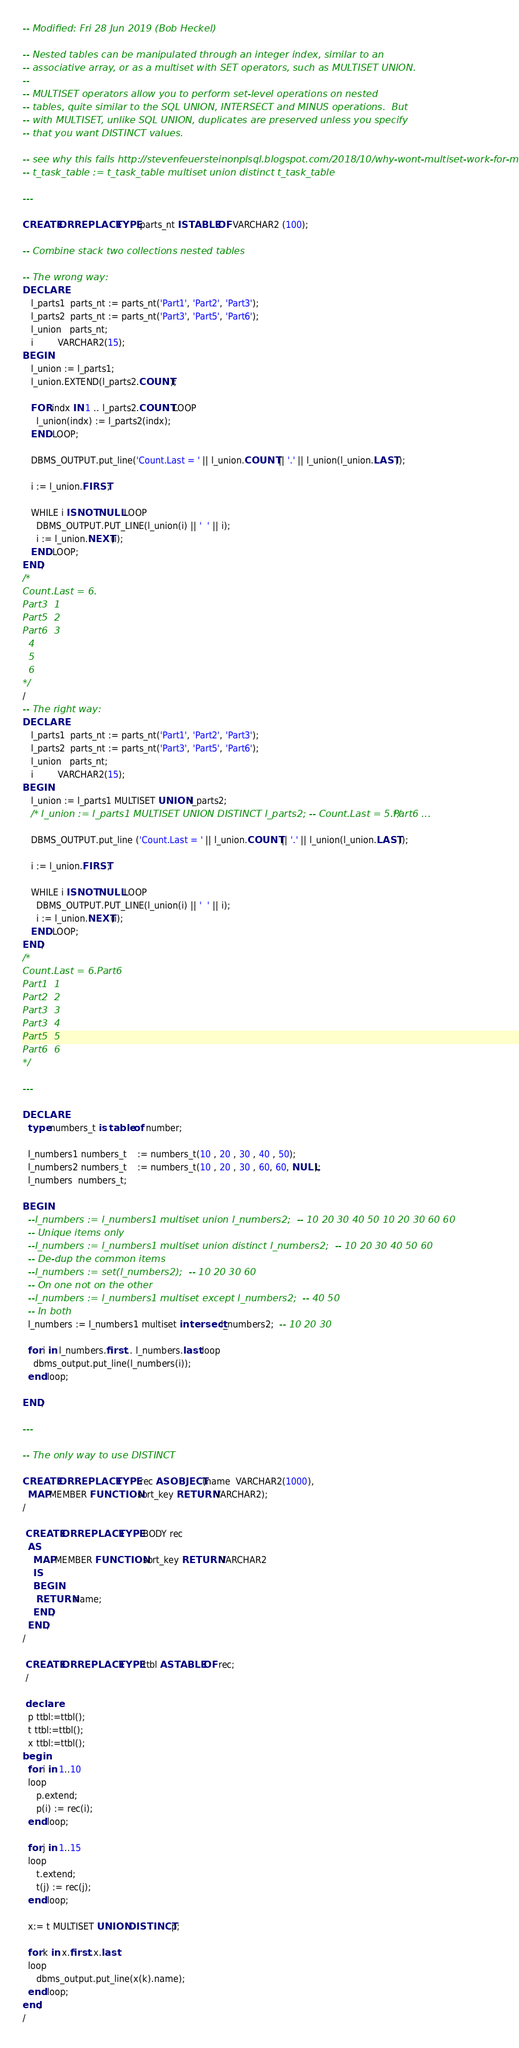Convert code to text. <code><loc_0><loc_0><loc_500><loc_500><_SQL_>-- Modified: Fri 28 Jun 2019 (Bob Heckel)

-- Nested tables can be manipulated through an integer index, similar to an
-- associative array, or as a multiset with SET operators, such as MULTISET UNION.
--
-- MULTISET operators allow you to perform set-level operations on nested
-- tables, quite similar to the SQL UNION, INTERSECT and MINUS operations.  But
-- with MULTISET, unlike SQL UNION, duplicates are preserved unless you specify 
-- that you want DISTINCT values.

-- see why this fails http://stevenfeuersteinonplsql.blogspot.com/2018/10/why-wont-multiset-work-for-me.html
-- t_task_table := t_task_table multiset union distinct t_task_table

---

CREATE OR REPLACE TYPE parts_nt IS TABLE OF VARCHAR2 (100);

-- Combine stack two collections nested tables

-- The wrong way:
DECLARE
   l_parts1  parts_nt := parts_nt('Part1', 'Part2', 'Part3');
   l_parts2  parts_nt := parts_nt('Part3', 'Part5', 'Part6');
   l_union   parts_nt;
   i         VARCHAR2(15);
BEGIN
   l_union := l_parts1;
   l_union.EXTEND(l_parts2.COUNT);

   FOR indx IN 1 .. l_parts2.COUNT LOOP
     l_union(indx) := l_parts2(indx);
   END LOOP;

   DBMS_OUTPUT.put_line('Count.Last = ' || l_union.COUNT || '.' || l_union(l_union.LAST));

   i := l_union.FIRST;
 
   WHILE i IS NOT NULL LOOP
     DBMS_OUTPUT.PUT_LINE(l_union(i) || '  ' || i);
     i := l_union.NEXT(i);
   END LOOP;
END;
/*
Count.Last = 6.
Part3  1
Part5  2
Part6  3
  4
  5
  6
*/
/
-- The right way:
DECLARE
   l_parts1  parts_nt := parts_nt('Part1', 'Part2', 'Part3');
   l_parts2  parts_nt := parts_nt('Part3', 'Part5', 'Part6');
   l_union   parts_nt;
   i         VARCHAR2(15);
BEGIN
   l_union := l_parts1 MULTISET UNION l_parts2;
   /* l_union := l_parts1 MULTISET UNION DISTINCT l_parts2; -- Count.Last = 5.Part6 ... */

   DBMS_OUTPUT.put_line ('Count.Last = ' || l_union.COUNT || '.' || l_union(l_union.LAST));

   i := l_union.FIRST;
 
   WHILE i IS NOT NULL LOOP
     DBMS_OUTPUT.PUT_LINE(l_union(i) || '  ' || i);
     i := l_union.NEXT(i);
   END LOOP;
END;
/*
Count.Last = 6.Part6
Part1  1
Part2  2
Part3  3
Part3  4
Part5  5
Part6  6
*/

---

DECLARE
  type numbers_t is table of number;

  l_numbers1 numbers_t    := numbers_t(10 , 20 , 30 , 40 , 50);
  l_numbers2 numbers_t    := numbers_t(10 , 20 , 30 , 60, 60, NULL);
  l_numbers  numbers_t;    

BEGIN
  --l_numbers := l_numbers1 multiset union l_numbers2;  -- 10 20 30 40 50 10 20 30 60 60
  -- Unique items only
  --l_numbers := l_numbers1 multiset union distinct l_numbers2;  -- 10 20 30 40 50 60
  -- De-dup the common items
  --l_numbers := set(l_numbers2);  -- 10 20 30 60
  -- On one not on the other
  --l_numbers := l_numbers1 multiset except l_numbers2;  -- 40 50
  -- In both
  l_numbers := l_numbers1 multiset intersect l_numbers2;  -- 10 20 30
  
  for i in l_numbers.first .. l_numbers.last loop
    dbms_output.put_line(l_numbers(i));
  end loop;
  
END;

---

-- The only way to use DISTINCT	

CREATE OR REPLACE TYPE rec AS OBJECT(name  VARCHAR2(1000),
  MAP MEMBER FUNCTION sort_key RETURN VARCHAR2);
/

 CREATE OR REPLACE TYPE BODY rec
  AS
    MAP MEMBER FUNCTION sort_key RETURN VARCHAR2
    IS
    BEGIN
  	 RETURN name;
    END;
  END;
/

 CREATE OR REPLACE TYPE ttbl AS TABLE OF rec;
 /

 declare
  p ttbl:=ttbl();
  t ttbl:=ttbl();
  x ttbl:=ttbl();
begin
  for i in 1..10
  loop
	 p.extend;
	 p(i) := rec(i);
  end loop;

  for j in 1..15
  loop
	 t.extend;
	 t(j) := rec(j);
  end loop;

  x:= t MULTISET UNION DISTINCT p;

  for k in x.first..x.last
  loop
	 dbms_output.put_line(x(k).name);
  end loop;
end;
/
</code> 